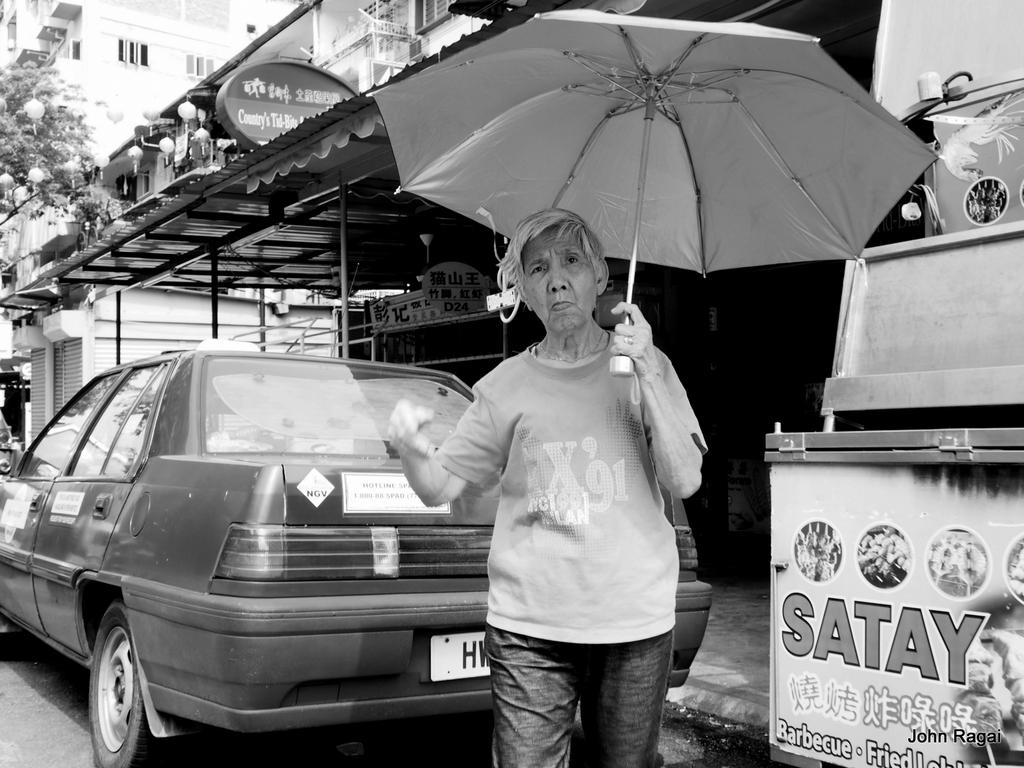What is the color scheme of the image? The image is in black and white. Who is the main subject in the image? There is a woman in the center of the image. What is the woman holding in the image? The woman is holding an umbrella. What can be seen behind the woman? There is a car behind the woman. What is visible in the background of the image? There are buildings, a board, poles, and trees in the background of the image. What type of pain is the woman experiencing in the image? There is no indication of pain in the image; the woman is holding an umbrella. What is the woman's role in the committee in the image? There is no committee or any reference to a committee in the image. 